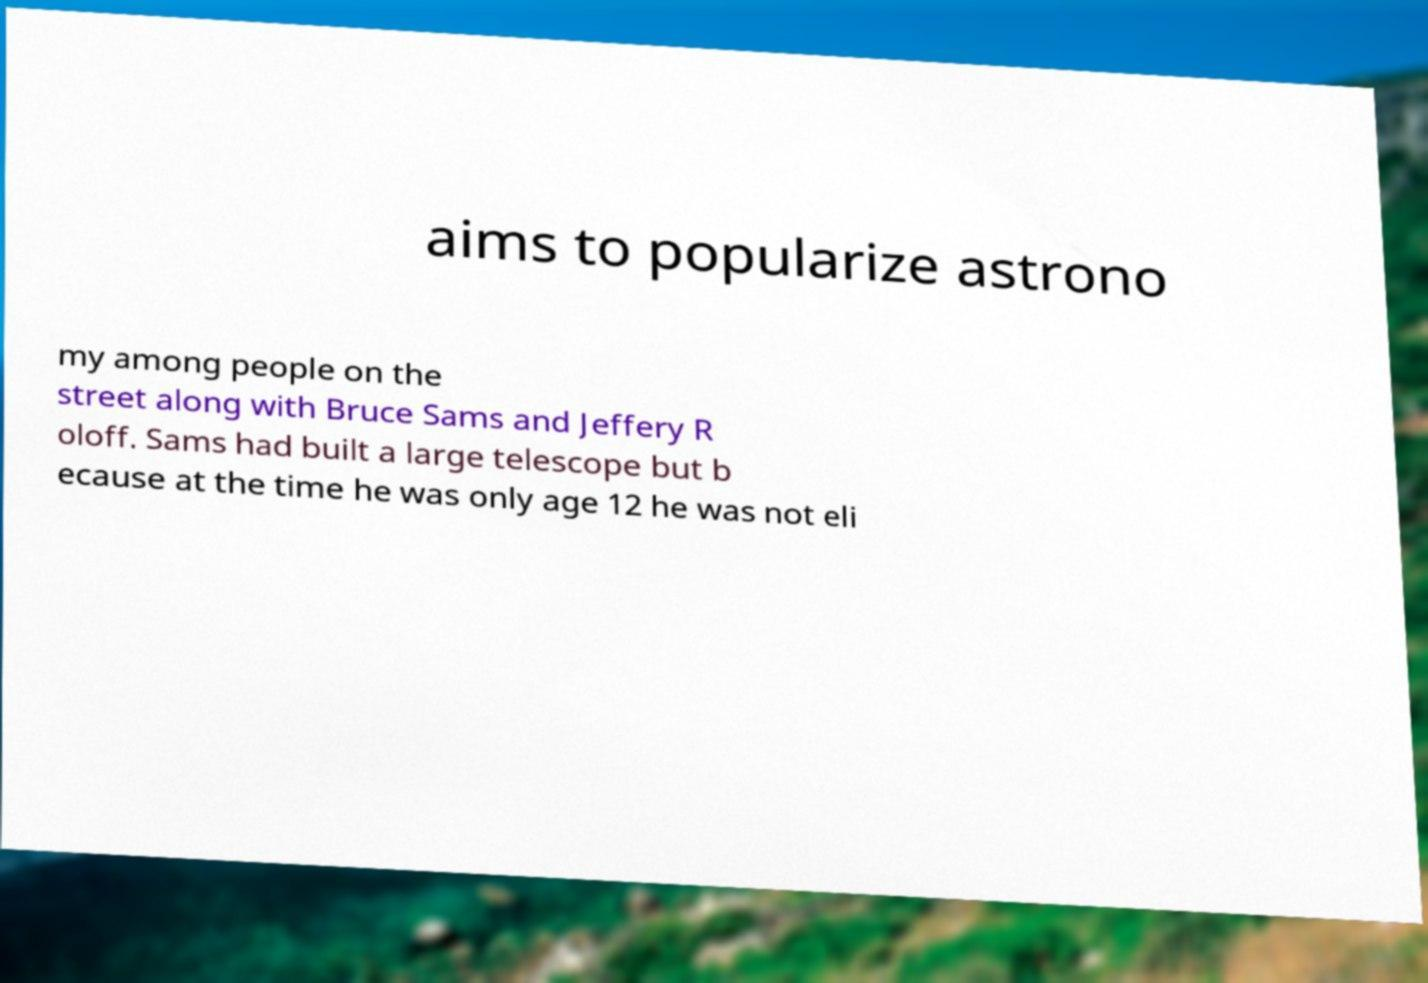I need the written content from this picture converted into text. Can you do that? aims to popularize astrono my among people on the street along with Bruce Sams and Jeffery R oloff. Sams had built a large telescope but b ecause at the time he was only age 12 he was not eli 